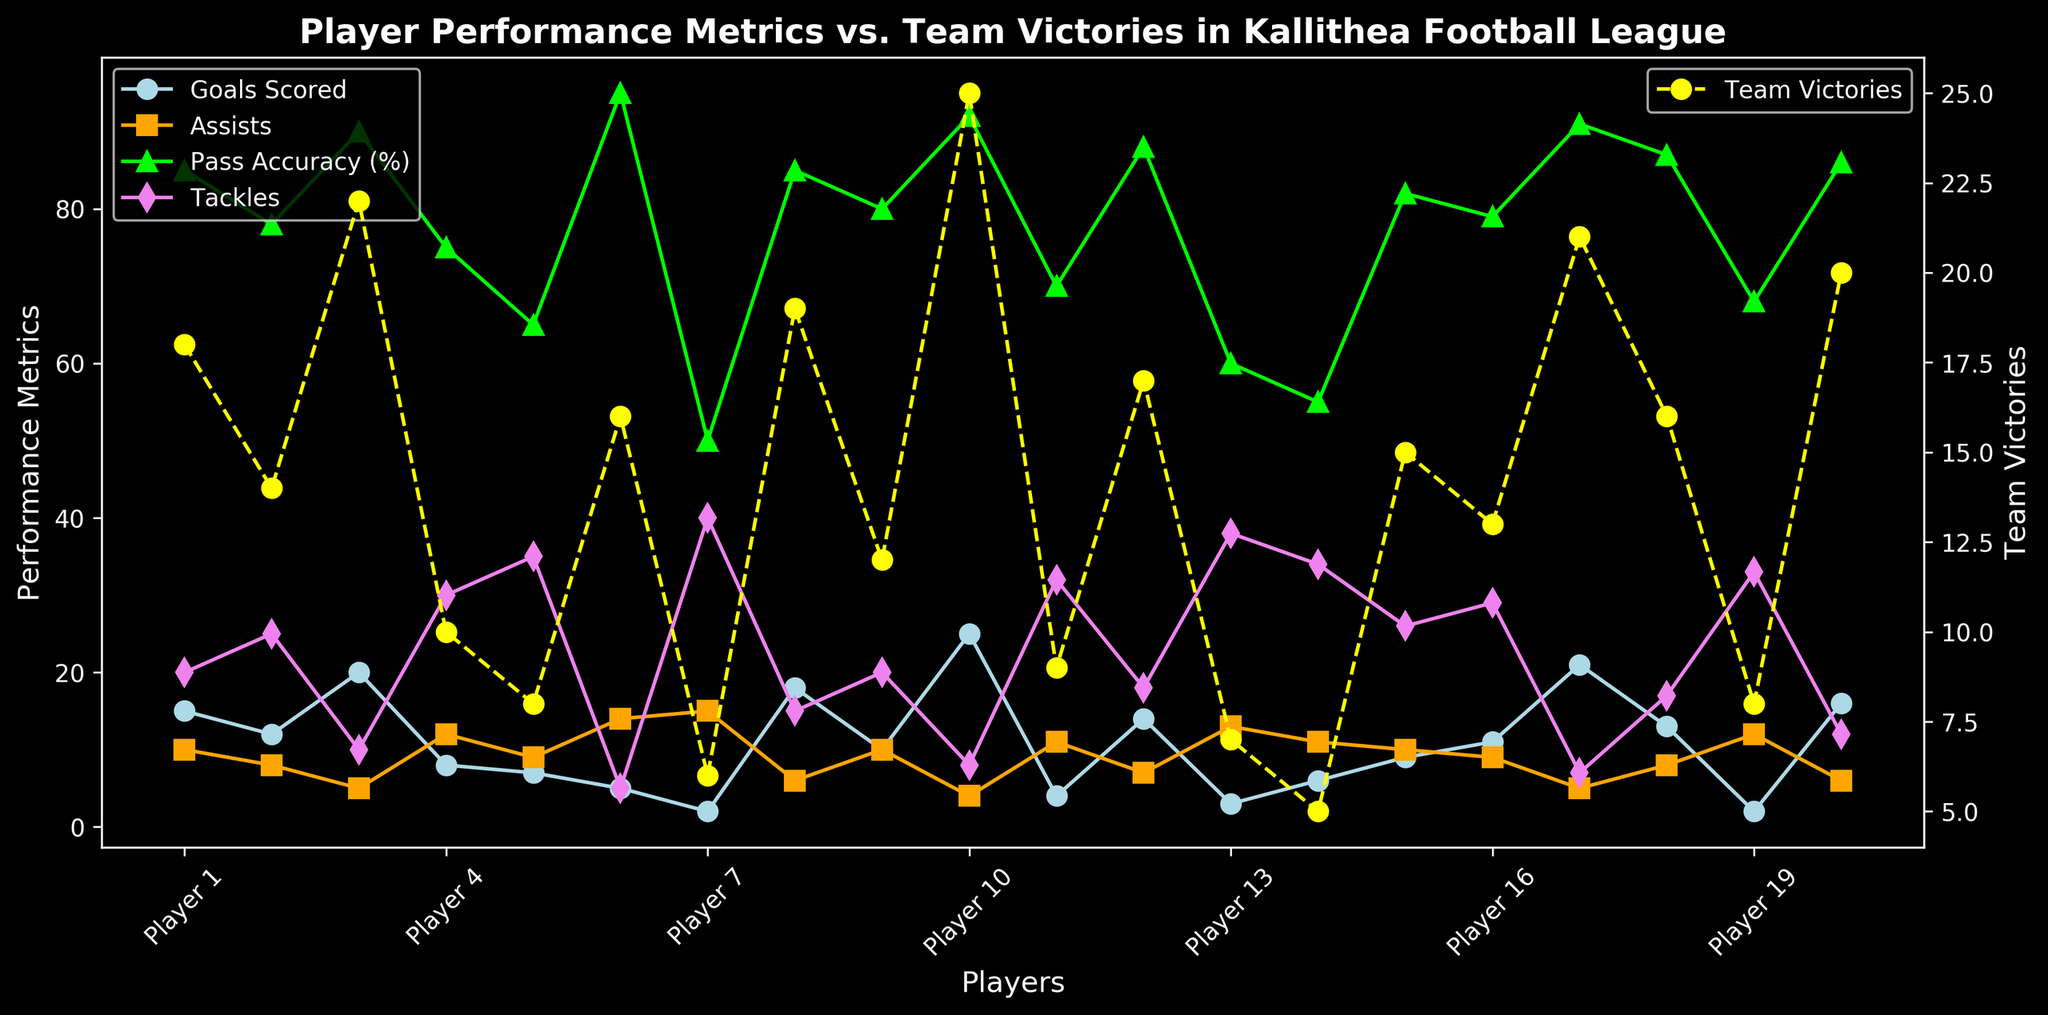What's the relationship between Pass Accuracy (%) and Team Victories for Player 10? Player 10 has a Pass Accuracy of 92% and their Team has 25 victories. Both values are at the higher end of the spectrum, indicating a possible correlation between high pass accuracy and more team victories.
Answer: High Pass Accuracy, More Victories Which player has the highest number of Tackles, and how many Team Victories do they have? From the figure, Player 7 has the highest number of Tackles (40). Player 7's team has 6 victories.
Answer: Player 7, 6 Victories Compare the Goals Scored and Assists for Player 3. How do these compare visually? Player 3 has scored 20 goals and made 5 assists. Visually, the 'Goals Scored' marker is higher than the 'Assists' marker in the graph showing a significant difference between the two.
Answer: 20 Goals, 5 Assists Calculate the average number of Pass Accuracy (%) for Players 2, 7, and 14. The Pass Accuracy percentages are 78% (Player 2), 50% (Player 7), and 55% (Player 14). Average = (78 + 50 + 55) / 3 = 61%
Answer: 61% How do the Goals Scored for Player 17 compare with their Team Victories? Player 17 has scored 21 goals. Their team has 21 victories, indicating a perfect match between the goals scored and victories achieved.
Answer: 21 Goals, 21 Victories What is the difference between the highest and lowest Pass Accuracy (%)? The highest Pass Accuracy is for Player 6 (95%), and the lowest is for Player 7 (50%). The difference is 95% - 50% = 45%.
Answer: 45% Identify the player with the highest Goals Scored and describe their Team's performance in terms of victories. Player 10 has the highest number of Goals Scored (25). Their team has the highest number of victories (25), showing a clear link between their top scoring and team success.
Answer: Player 10, 25 Victories Which player has an equal number of Goals Scored and Team Victories? Player 17 has both 21 Goals Scored and 21 Team Victories, indicating an equal contribution to both metrics.
Answer: Player 17 How many players have a Pass Accuracy (%) greater than 85%? Players with Pass Accuracy greater than 85% include Player 1, Player 6, Player 8, Player 10, Player 12, Player 17, and Player 20. Counting them, there are 7 players.
Answer: 7 Do players with more Tackles seem to have more Team Victories? Provide an example to support your answer. Generally, players with more Tackles don't correlate with more Team Victories. For example, Player 7 has 40 Tackles but only 6 victories, whereas Player 3 has 10 Tackles but 22 victories.
Answer: No correlation, 6 Victories (Player 7), 22 Victories (Player 3) 